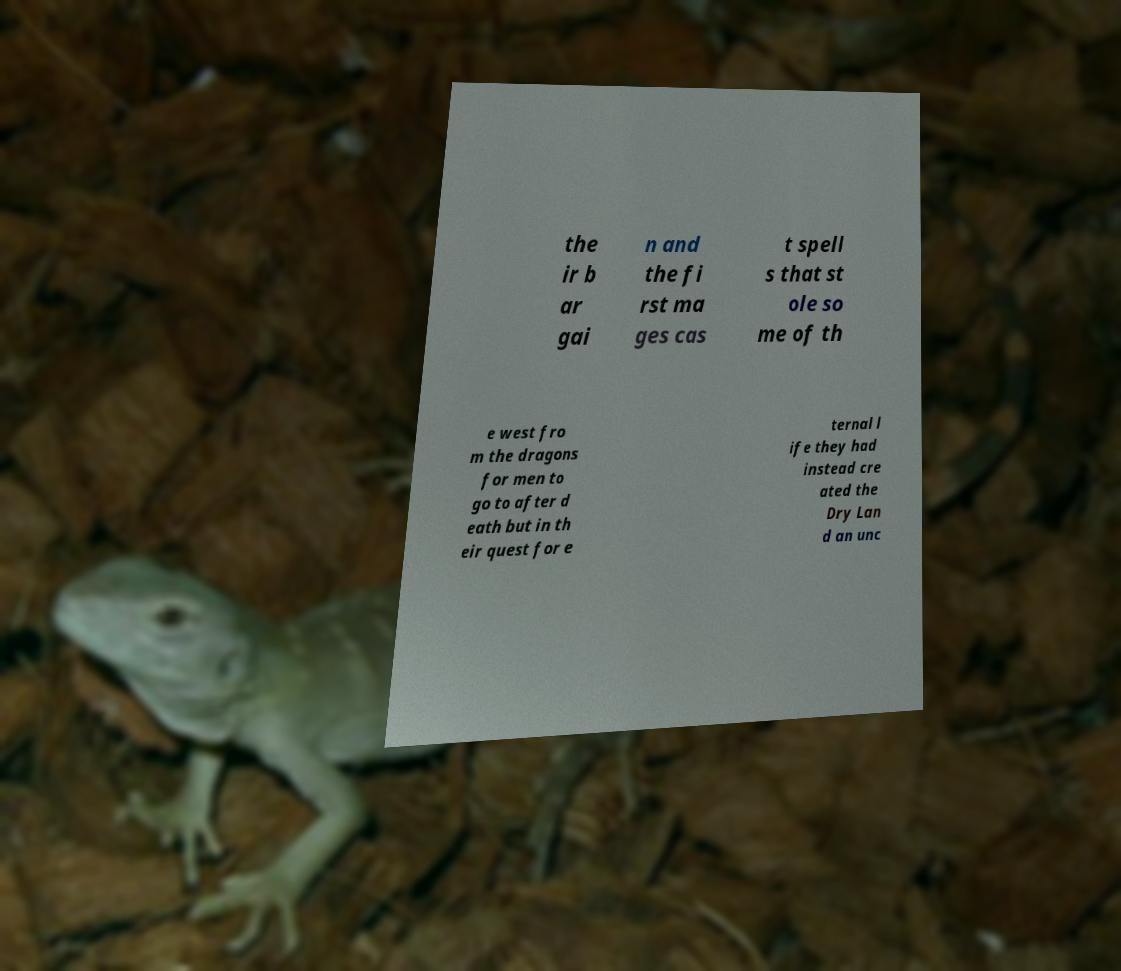Please read and relay the text visible in this image. What does it say? the ir b ar gai n and the fi rst ma ges cas t spell s that st ole so me of th e west fro m the dragons for men to go to after d eath but in th eir quest for e ternal l ife they had instead cre ated the Dry Lan d an unc 